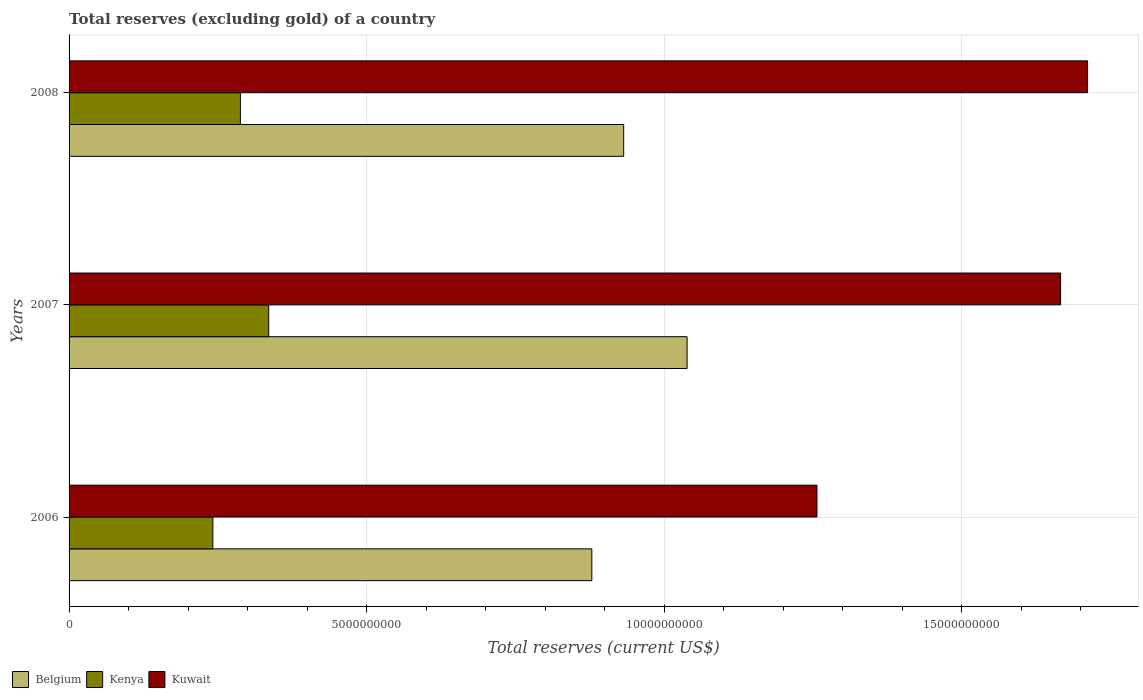How many groups of bars are there?
Keep it short and to the point. 3. Are the number of bars per tick equal to the number of legend labels?
Provide a short and direct response. Yes. How many bars are there on the 2nd tick from the top?
Keep it short and to the point. 3. In how many cases, is the number of bars for a given year not equal to the number of legend labels?
Make the answer very short. 0. What is the total reserves (excluding gold) in Kenya in 2006?
Provide a short and direct response. 2.42e+09. Across all years, what is the maximum total reserves (excluding gold) in Kuwait?
Offer a very short reply. 1.71e+1. Across all years, what is the minimum total reserves (excluding gold) in Kuwait?
Provide a short and direct response. 1.26e+1. In which year was the total reserves (excluding gold) in Belgium maximum?
Keep it short and to the point. 2007. What is the total total reserves (excluding gold) in Kenya in the graph?
Your answer should be compact. 8.65e+09. What is the difference between the total reserves (excluding gold) in Kenya in 2007 and that in 2008?
Give a very brief answer. 4.76e+08. What is the difference between the total reserves (excluding gold) in Kuwait in 2006 and the total reserves (excluding gold) in Kenya in 2008?
Provide a succinct answer. 9.69e+09. What is the average total reserves (excluding gold) in Kenya per year?
Provide a succinct answer. 2.88e+09. In the year 2007, what is the difference between the total reserves (excluding gold) in Kuwait and total reserves (excluding gold) in Kenya?
Provide a short and direct response. 1.33e+1. In how many years, is the total reserves (excluding gold) in Kuwait greater than 11000000000 US$?
Make the answer very short. 3. What is the ratio of the total reserves (excluding gold) in Kenya in 2006 to that in 2007?
Offer a terse response. 0.72. Is the total reserves (excluding gold) in Kenya in 2006 less than that in 2007?
Ensure brevity in your answer.  Yes. Is the difference between the total reserves (excluding gold) in Kuwait in 2006 and 2007 greater than the difference between the total reserves (excluding gold) in Kenya in 2006 and 2007?
Give a very brief answer. No. What is the difference between the highest and the second highest total reserves (excluding gold) in Belgium?
Your answer should be compact. 1.07e+09. What is the difference between the highest and the lowest total reserves (excluding gold) in Belgium?
Offer a terse response. 1.60e+09. Is the sum of the total reserves (excluding gold) in Kuwait in 2006 and 2007 greater than the maximum total reserves (excluding gold) in Kenya across all years?
Ensure brevity in your answer.  Yes. What does the 1st bar from the top in 2007 represents?
Provide a short and direct response. Kuwait. What does the 2nd bar from the bottom in 2008 represents?
Provide a short and direct response. Kenya. How many years are there in the graph?
Provide a short and direct response. 3. Are the values on the major ticks of X-axis written in scientific E-notation?
Provide a succinct answer. No. How are the legend labels stacked?
Your response must be concise. Horizontal. What is the title of the graph?
Your answer should be compact. Total reserves (excluding gold) of a country. Does "Philippines" appear as one of the legend labels in the graph?
Give a very brief answer. No. What is the label or title of the X-axis?
Offer a terse response. Total reserves (current US$). What is the Total reserves (current US$) of Belgium in 2006?
Make the answer very short. 8.78e+09. What is the Total reserves (current US$) in Kenya in 2006?
Offer a very short reply. 2.42e+09. What is the Total reserves (current US$) of Kuwait in 2006?
Keep it short and to the point. 1.26e+1. What is the Total reserves (current US$) in Belgium in 2007?
Offer a terse response. 1.04e+1. What is the Total reserves (current US$) of Kenya in 2007?
Your answer should be very brief. 3.36e+09. What is the Total reserves (current US$) of Kuwait in 2007?
Provide a short and direct response. 1.67e+1. What is the Total reserves (current US$) of Belgium in 2008?
Provide a short and direct response. 9.32e+09. What is the Total reserves (current US$) in Kenya in 2008?
Provide a succinct answer. 2.88e+09. What is the Total reserves (current US$) of Kuwait in 2008?
Give a very brief answer. 1.71e+1. Across all years, what is the maximum Total reserves (current US$) in Belgium?
Your response must be concise. 1.04e+1. Across all years, what is the maximum Total reserves (current US$) of Kenya?
Make the answer very short. 3.36e+09. Across all years, what is the maximum Total reserves (current US$) in Kuwait?
Offer a very short reply. 1.71e+1. Across all years, what is the minimum Total reserves (current US$) of Belgium?
Give a very brief answer. 8.78e+09. Across all years, what is the minimum Total reserves (current US$) of Kenya?
Make the answer very short. 2.42e+09. Across all years, what is the minimum Total reserves (current US$) of Kuwait?
Provide a short and direct response. 1.26e+1. What is the total Total reserves (current US$) of Belgium in the graph?
Provide a succinct answer. 2.85e+1. What is the total Total reserves (current US$) of Kenya in the graph?
Make the answer very short. 8.65e+09. What is the total Total reserves (current US$) in Kuwait in the graph?
Provide a short and direct response. 4.63e+1. What is the difference between the Total reserves (current US$) in Belgium in 2006 and that in 2007?
Provide a succinct answer. -1.60e+09. What is the difference between the Total reserves (current US$) in Kenya in 2006 and that in 2007?
Offer a very short reply. -9.39e+08. What is the difference between the Total reserves (current US$) in Kuwait in 2006 and that in 2007?
Provide a succinct answer. -4.09e+09. What is the difference between the Total reserves (current US$) in Belgium in 2006 and that in 2008?
Offer a terse response. -5.35e+08. What is the difference between the Total reserves (current US$) in Kenya in 2006 and that in 2008?
Offer a terse response. -4.63e+08. What is the difference between the Total reserves (current US$) in Kuwait in 2006 and that in 2008?
Provide a short and direct response. -4.55e+09. What is the difference between the Total reserves (current US$) in Belgium in 2007 and that in 2008?
Your answer should be very brief. 1.07e+09. What is the difference between the Total reserves (current US$) of Kenya in 2007 and that in 2008?
Provide a succinct answer. 4.76e+08. What is the difference between the Total reserves (current US$) of Kuwait in 2007 and that in 2008?
Provide a short and direct response. -4.53e+08. What is the difference between the Total reserves (current US$) in Belgium in 2006 and the Total reserves (current US$) in Kenya in 2007?
Provide a short and direct response. 5.43e+09. What is the difference between the Total reserves (current US$) in Belgium in 2006 and the Total reserves (current US$) in Kuwait in 2007?
Provide a short and direct response. -7.88e+09. What is the difference between the Total reserves (current US$) in Kenya in 2006 and the Total reserves (current US$) in Kuwait in 2007?
Provide a short and direct response. -1.42e+1. What is the difference between the Total reserves (current US$) of Belgium in 2006 and the Total reserves (current US$) of Kenya in 2008?
Keep it short and to the point. 5.90e+09. What is the difference between the Total reserves (current US$) of Belgium in 2006 and the Total reserves (current US$) of Kuwait in 2008?
Make the answer very short. -8.33e+09. What is the difference between the Total reserves (current US$) of Kenya in 2006 and the Total reserves (current US$) of Kuwait in 2008?
Provide a succinct answer. -1.47e+1. What is the difference between the Total reserves (current US$) of Belgium in 2007 and the Total reserves (current US$) of Kenya in 2008?
Offer a terse response. 7.51e+09. What is the difference between the Total reserves (current US$) of Belgium in 2007 and the Total reserves (current US$) of Kuwait in 2008?
Ensure brevity in your answer.  -6.73e+09. What is the difference between the Total reserves (current US$) in Kenya in 2007 and the Total reserves (current US$) in Kuwait in 2008?
Keep it short and to the point. -1.38e+1. What is the average Total reserves (current US$) in Belgium per year?
Your answer should be very brief. 9.50e+09. What is the average Total reserves (current US$) in Kenya per year?
Make the answer very short. 2.88e+09. What is the average Total reserves (current US$) of Kuwait per year?
Make the answer very short. 1.54e+1. In the year 2006, what is the difference between the Total reserves (current US$) of Belgium and Total reserves (current US$) of Kenya?
Your answer should be very brief. 6.37e+09. In the year 2006, what is the difference between the Total reserves (current US$) in Belgium and Total reserves (current US$) in Kuwait?
Give a very brief answer. -3.78e+09. In the year 2006, what is the difference between the Total reserves (current US$) in Kenya and Total reserves (current US$) in Kuwait?
Keep it short and to the point. -1.02e+1. In the year 2007, what is the difference between the Total reserves (current US$) of Belgium and Total reserves (current US$) of Kenya?
Provide a short and direct response. 7.03e+09. In the year 2007, what is the difference between the Total reserves (current US$) in Belgium and Total reserves (current US$) in Kuwait?
Provide a succinct answer. -6.28e+09. In the year 2007, what is the difference between the Total reserves (current US$) in Kenya and Total reserves (current US$) in Kuwait?
Your answer should be very brief. -1.33e+1. In the year 2008, what is the difference between the Total reserves (current US$) in Belgium and Total reserves (current US$) in Kenya?
Give a very brief answer. 6.44e+09. In the year 2008, what is the difference between the Total reserves (current US$) of Belgium and Total reserves (current US$) of Kuwait?
Your response must be concise. -7.79e+09. In the year 2008, what is the difference between the Total reserves (current US$) of Kenya and Total reserves (current US$) of Kuwait?
Make the answer very short. -1.42e+1. What is the ratio of the Total reserves (current US$) of Belgium in 2006 to that in 2007?
Your response must be concise. 0.85. What is the ratio of the Total reserves (current US$) of Kenya in 2006 to that in 2007?
Make the answer very short. 0.72. What is the ratio of the Total reserves (current US$) of Kuwait in 2006 to that in 2007?
Offer a terse response. 0.75. What is the ratio of the Total reserves (current US$) in Belgium in 2006 to that in 2008?
Offer a terse response. 0.94. What is the ratio of the Total reserves (current US$) in Kenya in 2006 to that in 2008?
Give a very brief answer. 0.84. What is the ratio of the Total reserves (current US$) in Kuwait in 2006 to that in 2008?
Provide a short and direct response. 0.73. What is the ratio of the Total reserves (current US$) in Belgium in 2007 to that in 2008?
Your answer should be compact. 1.11. What is the ratio of the Total reserves (current US$) of Kenya in 2007 to that in 2008?
Provide a succinct answer. 1.17. What is the ratio of the Total reserves (current US$) of Kuwait in 2007 to that in 2008?
Make the answer very short. 0.97. What is the difference between the highest and the second highest Total reserves (current US$) of Belgium?
Ensure brevity in your answer.  1.07e+09. What is the difference between the highest and the second highest Total reserves (current US$) in Kenya?
Provide a succinct answer. 4.76e+08. What is the difference between the highest and the second highest Total reserves (current US$) in Kuwait?
Provide a succinct answer. 4.53e+08. What is the difference between the highest and the lowest Total reserves (current US$) in Belgium?
Offer a very short reply. 1.60e+09. What is the difference between the highest and the lowest Total reserves (current US$) of Kenya?
Keep it short and to the point. 9.39e+08. What is the difference between the highest and the lowest Total reserves (current US$) in Kuwait?
Offer a terse response. 4.55e+09. 